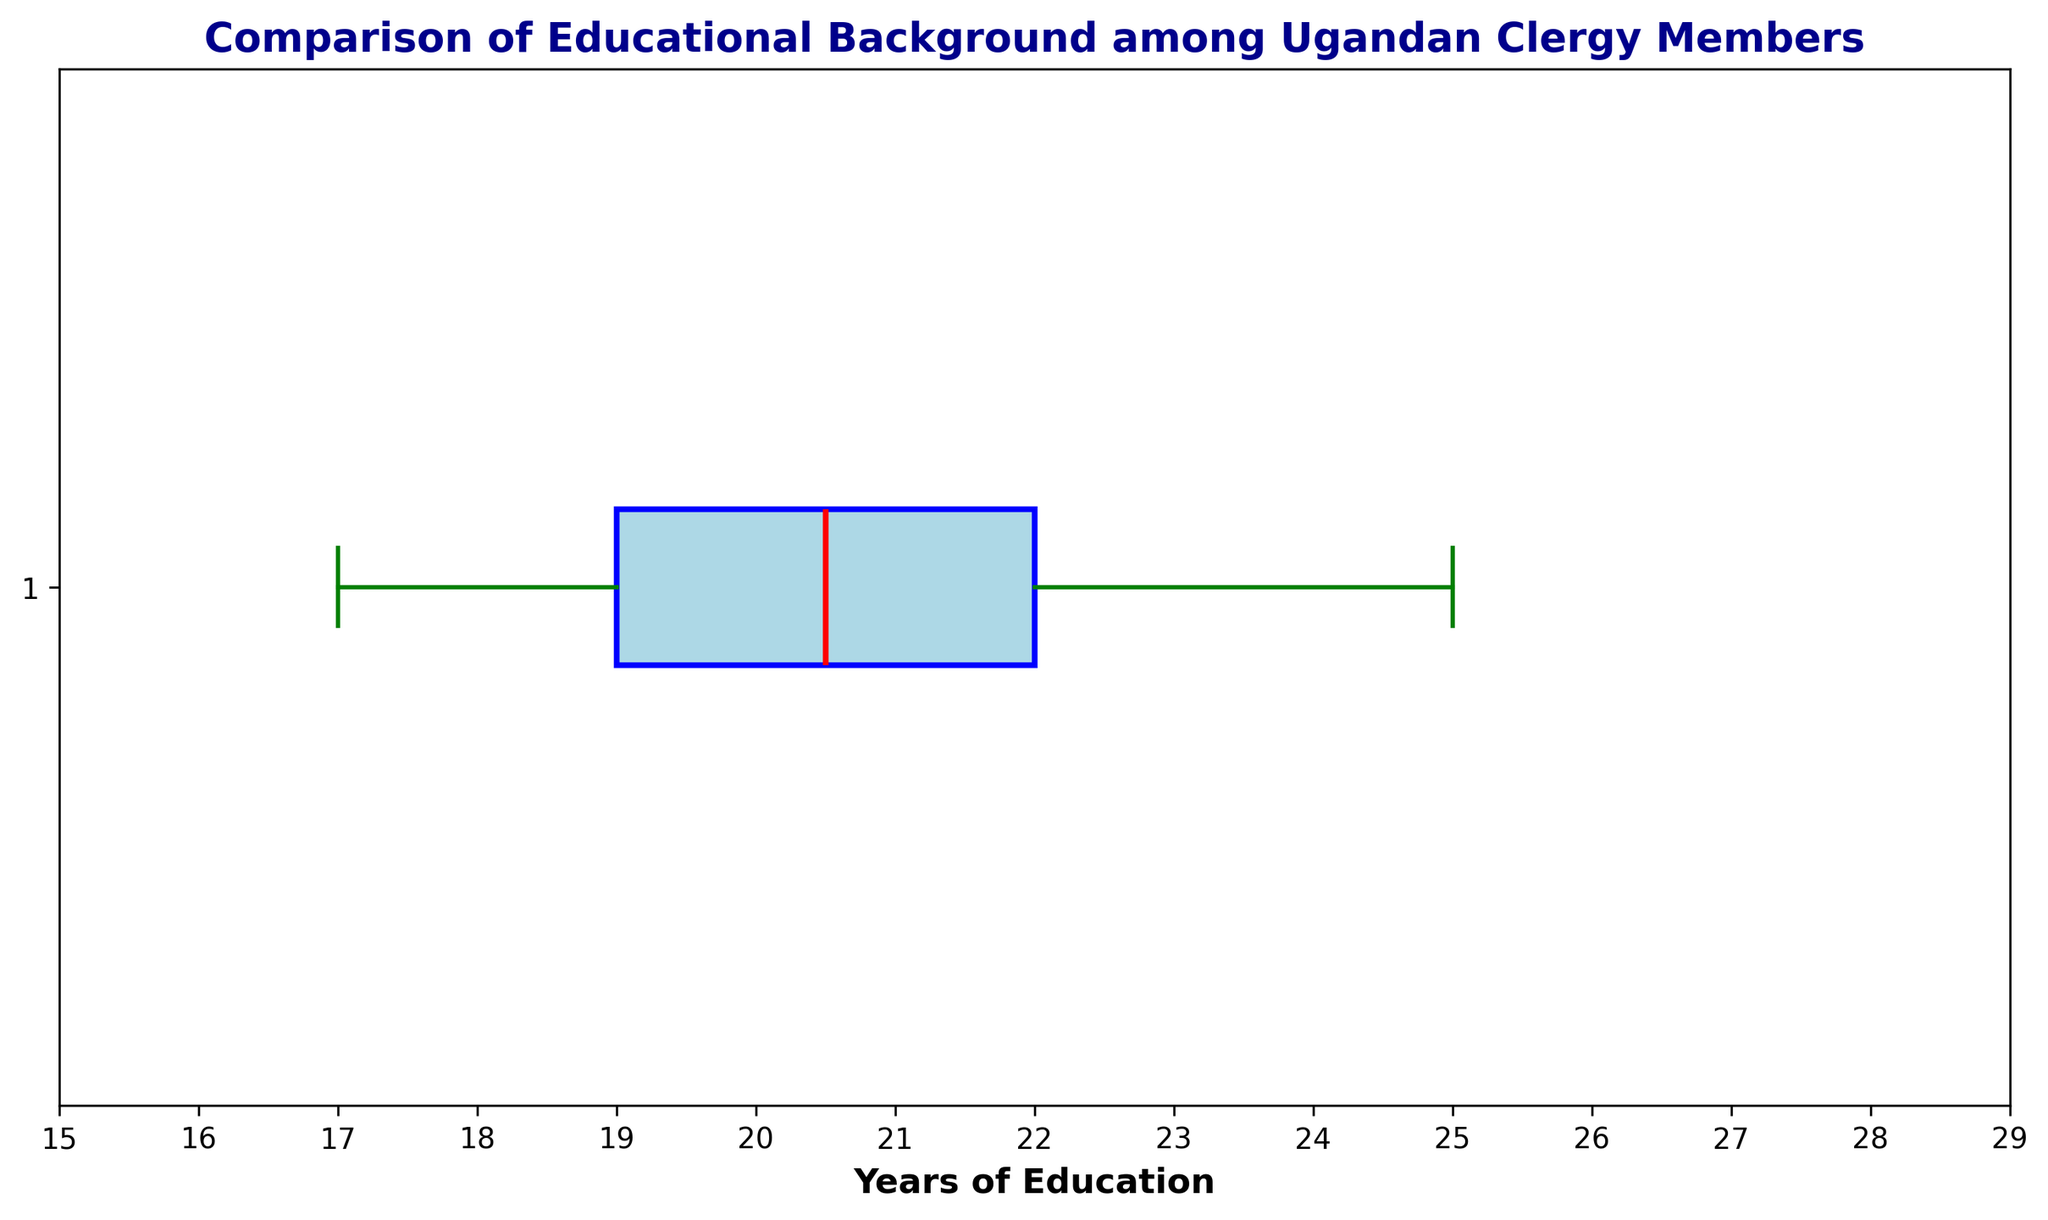What is the median educational background among the Ugandan clergy members? The red line in the box plot represents the median of the educational years.
Answer: 21 years What is the interquartile range (IQR) of the educational years? The IQR is found by subtracting the first quartile (Q1, the left edge of the box) from the third quartile (Q3, the right edge of the box). From the plot, Q1 is around 19 and Q3 is around 23. Thus, IQR = Q3 - Q1 = 23 - 19 = 4.
Answer: 4 years Which clergy member has an education that falls outside the whiskers (outliers)? Outliers are represented by individual points outside the whiskers. The whiskers extend to the minimum and maximum values within 1.5 times the IQR from the quartiles. From the plot, points beyond these whiskers are not explicitly mentioned, but they could have values distinctly different from 17 to 25 years, therefore, one has to look for such members.
Answer: Points beyond 17 or 25 years How does the range of educational years compare to the IQR? The range is the difference between the maximum and minimum values; from 17 to 25 years, which is 25 - 17 = 8. Compare it to the IQR of 4 years to understand the spread within the middle 50% and the overall spread.
Answer: Range is 8 years, IQR is 4 years What is the color of the median line in the box plot? The color of the median line in the box plot is red, as specified in the plot's legend.
Answer: Red Which visual attributes represent the first and third quartiles? The edges of the box represent the first (Q1) and third quartiles (Q3). The left edge of the box (Q1) falls around 19 years and the right edge of the box (Q3) falls around 23 years.
Answer: Box edges How many education years are represented between the bottom and top whiskers? The whiskers extend to the minimum (17 years) and maximum (25 years) values within 1.5 times the IQR from the quartiles. Therefore, 25 - 17 = 8 years are represented.
Answer: 8 years Where do most clergy members' educational years cluster around? The box in a box plot represents the interquartile range where the middle 50% of the data lies. This box lies between 19 and 23 years, indicating a clustering around these values.
Answer: 19 to 23 years If you were to place a new data point within the interquartile range, what range of values could it fall into? The interquartile range (IQR) is between the first quartile (Q1) and the third quartile (Q3). Thus, a new data point within the IQR would fall between 19 and 23 years.
Answer: 19 to 23 years 